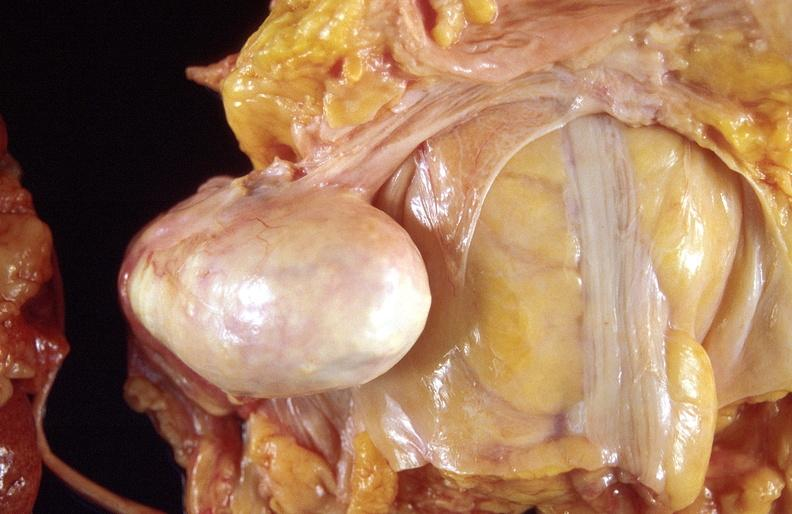what does this image show?
Answer the question using a single word or phrase. Dermoid cyst 